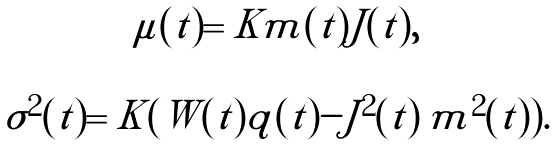Convert formula to latex. <formula><loc_0><loc_0><loc_500><loc_500>\begin{array} { c l } \mu ( t ) = K m ( t ) J ( t ) , & \\ & \\ \sigma ^ { 2 } ( t ) = K ( W ( t ) q ( t ) - J ^ { 2 } ( t ) \, m ^ { 2 } ( t ) ) . & \end{array}</formula> 